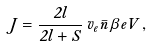Convert formula to latex. <formula><loc_0><loc_0><loc_500><loc_500>J = \frac { 2 l } { 2 l + S } \, v _ { e } \bar { n } \, \beta e V \, ,</formula> 